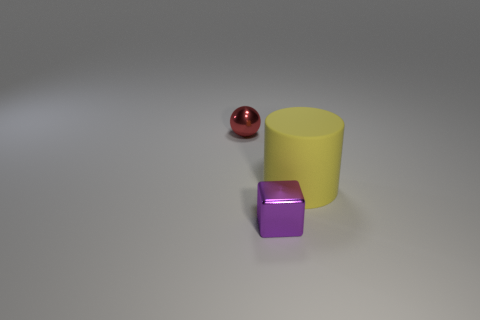The large cylinder that is right of the small thing that is on the left side of the object that is in front of the large yellow matte cylinder is made of what material?
Keep it short and to the point. Rubber. Do the matte cylinder and the metal object that is in front of the metal ball have the same size?
Ensure brevity in your answer.  No. There is a thing that is to the left of the tiny shiny thing on the right side of the sphere that is behind the cylinder; how big is it?
Your answer should be very brief. Small. Is the size of the matte thing the same as the red shiny ball?
Provide a succinct answer. No. The tiny thing behind the shiny object in front of the metallic ball is made of what material?
Your answer should be very brief. Metal. There is a tiny shiny object that is behind the big cylinder; does it have the same shape as the small shiny object in front of the yellow rubber object?
Your answer should be very brief. No. Are there an equal number of purple things that are on the left side of the big yellow matte cylinder and cylinders?
Ensure brevity in your answer.  Yes. There is a tiny metallic object in front of the red sphere; is there a tiny metal cube that is left of it?
Your answer should be compact. No. Are there any other things that have the same color as the small cube?
Your answer should be compact. No. Is the material of the small thing behind the big rubber object the same as the large cylinder?
Make the answer very short. No. 